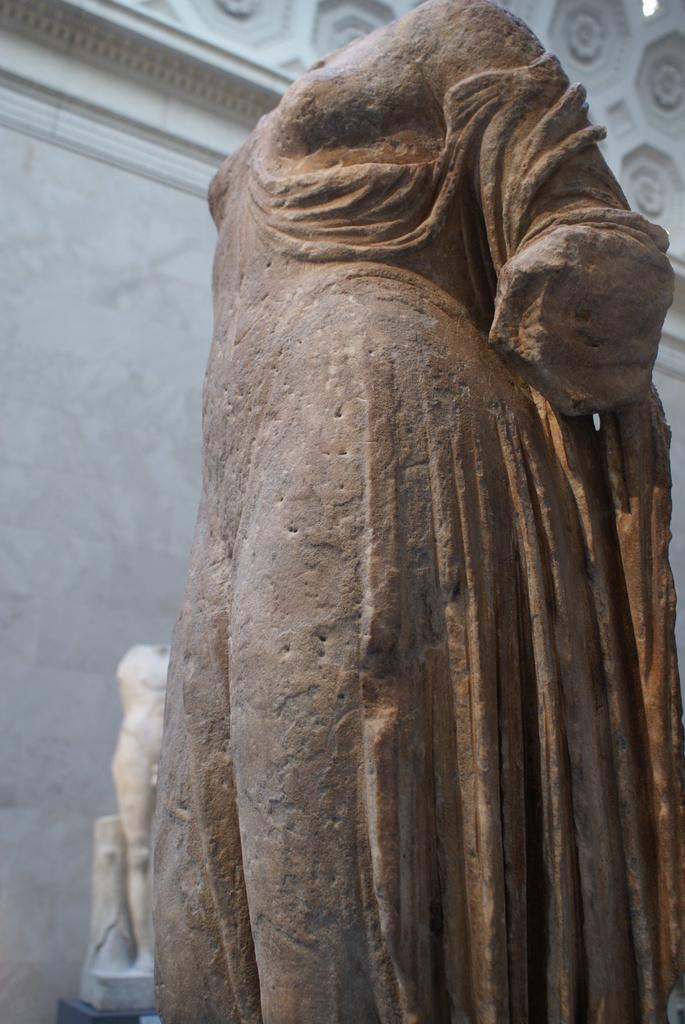What type of objects can be seen in the image? There are stone statues in the image. What material is the wall made of in the image? There is a marble wall in the image. What type of insect can be seen crawling on the stone statues in the image? There are no insects visible in the image; it only features stone statues and a marble wall. 